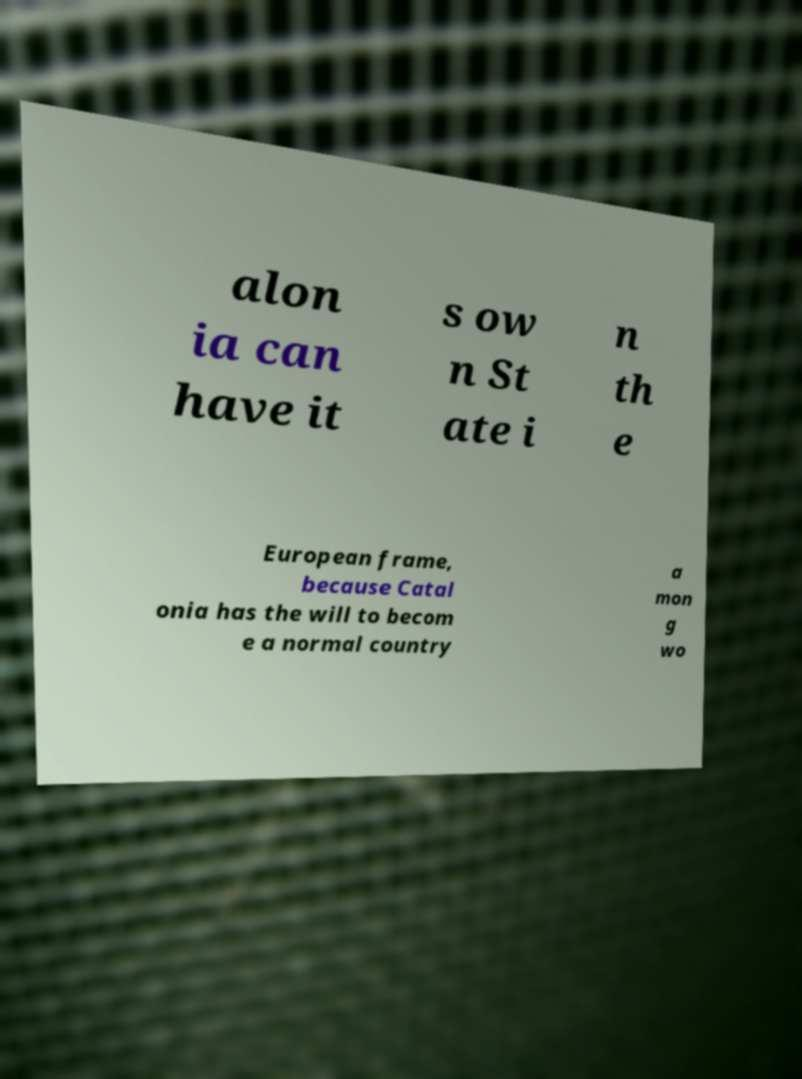Can you read and provide the text displayed in the image?This photo seems to have some interesting text. Can you extract and type it out for me? alon ia can have it s ow n St ate i n th e European frame, because Catal onia has the will to becom e a normal country a mon g wo 